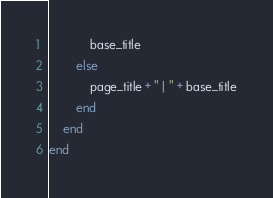Convert code to text. <code><loc_0><loc_0><loc_500><loc_500><_Ruby_>			base_title
		else
			page_title + " | " + base_title
		end
	end
end
</code> 